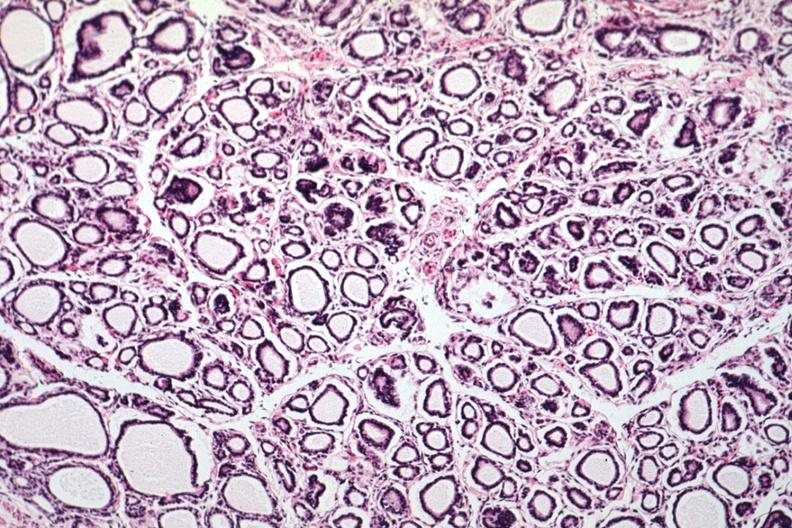s thyroid present?
Answer the question using a single word or phrase. Yes 